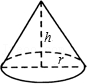How can you calculate the volume of this cone? The volume of the cone can be calculated using the formula V = (1/3)πr²h, where 'r' is the radius of the base, and 'h' is the height from the base to the apex. The 'π' represents Pi, which is approximately equal to 3.14159. This formula gives the volume in cubic units based on the units used for the radius and height. 